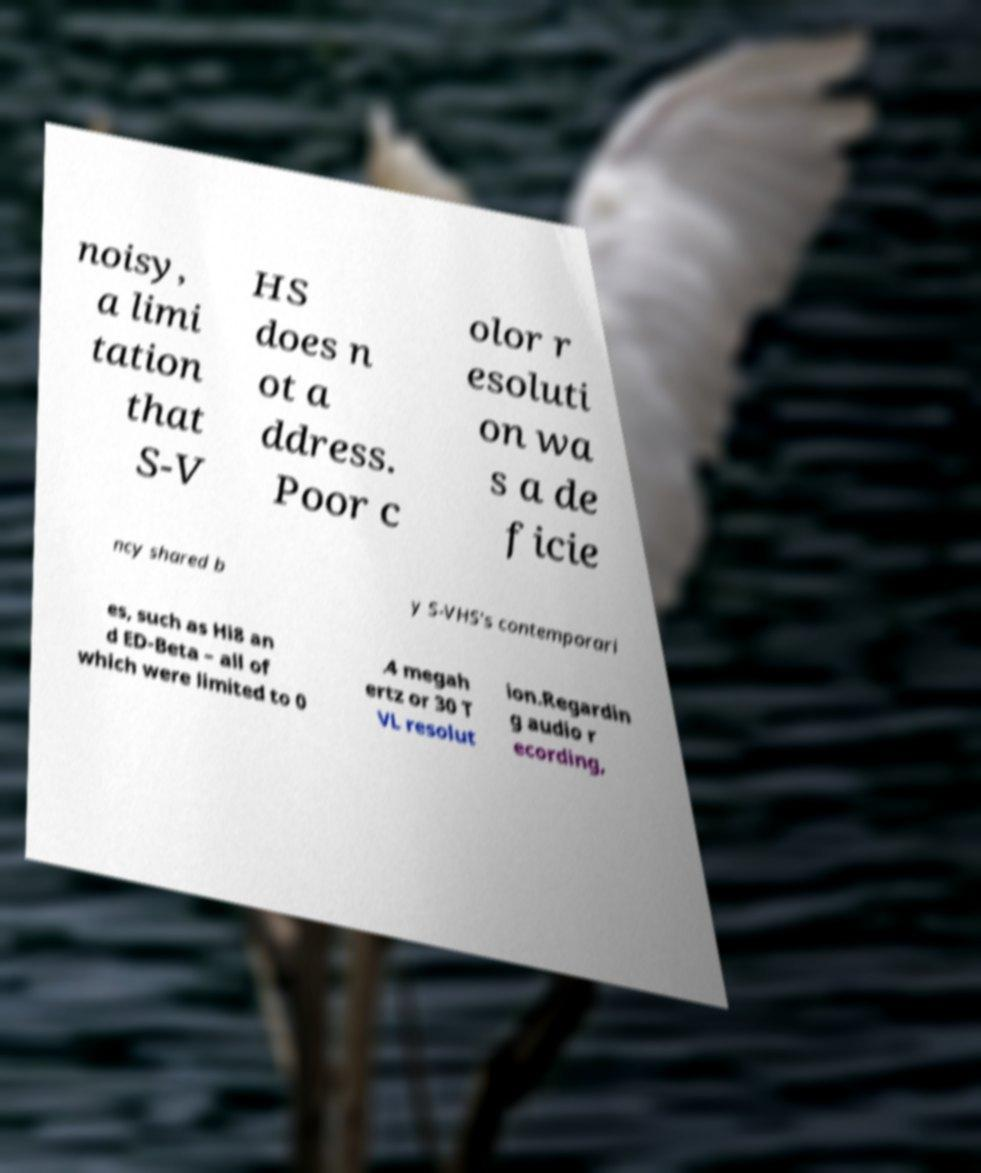Can you accurately transcribe the text from the provided image for me? noisy, a limi tation that S-V HS does n ot a ddress. Poor c olor r esoluti on wa s a de ficie ncy shared b y S-VHS's contemporari es, such as Hi8 an d ED-Beta – all of which were limited to 0 .4 megah ertz or 30 T VL resolut ion.Regardin g audio r ecording, 